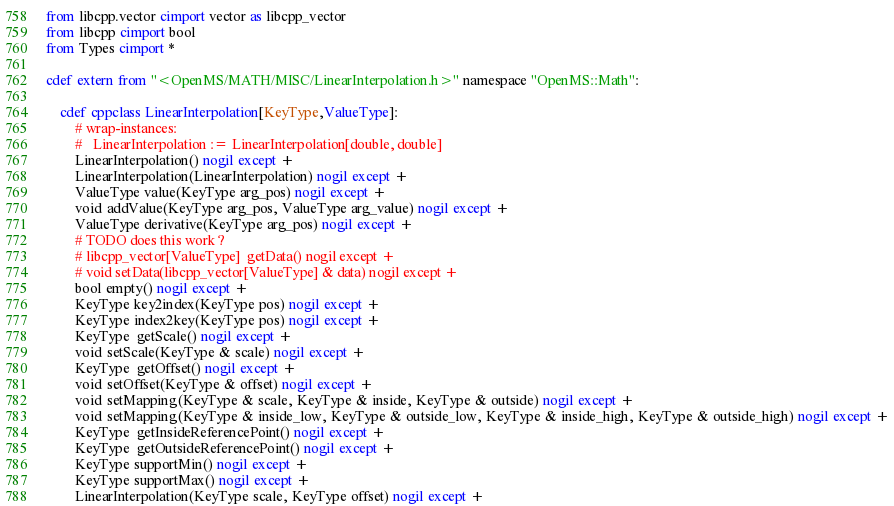Convert code to text. <code><loc_0><loc_0><loc_500><loc_500><_Cython_>from libcpp.vector cimport vector as libcpp_vector
from libcpp cimport bool
from Types cimport *

cdef extern from "<OpenMS/MATH/MISC/LinearInterpolation.h>" namespace "OpenMS::Math":
    
    cdef cppclass LinearInterpolation[KeyType,ValueType]:
        # wrap-instances:
        #   LinearInterpolation := LinearInterpolation[double, double]
        LinearInterpolation() nogil except +
        LinearInterpolation(LinearInterpolation) nogil except +
        ValueType value(KeyType arg_pos) nogil except +
        void addValue(KeyType arg_pos, ValueType arg_value) nogil except +
        ValueType derivative(KeyType arg_pos) nogil except +
        # TODO does this work ?
        # libcpp_vector[ValueType]  getData() nogil except +
        # void setData(libcpp_vector[ValueType] & data) nogil except +
        bool empty() nogil except +
        KeyType key2index(KeyType pos) nogil except +
        KeyType index2key(KeyType pos) nogil except +
        KeyType  getScale() nogil except +
        void setScale(KeyType & scale) nogil except +
        KeyType  getOffset() nogil except +
        void setOffset(KeyType & offset) nogil except +
        void setMapping(KeyType & scale, KeyType & inside, KeyType & outside) nogil except +
        void setMapping(KeyType & inside_low, KeyType & outside_low, KeyType & inside_high, KeyType & outside_high) nogil except +
        KeyType  getInsideReferencePoint() nogil except +
        KeyType  getOutsideReferencePoint() nogil except +
        KeyType supportMin() nogil except +
        KeyType supportMax() nogil except +
        LinearInterpolation(KeyType scale, KeyType offset) nogil except +

</code> 